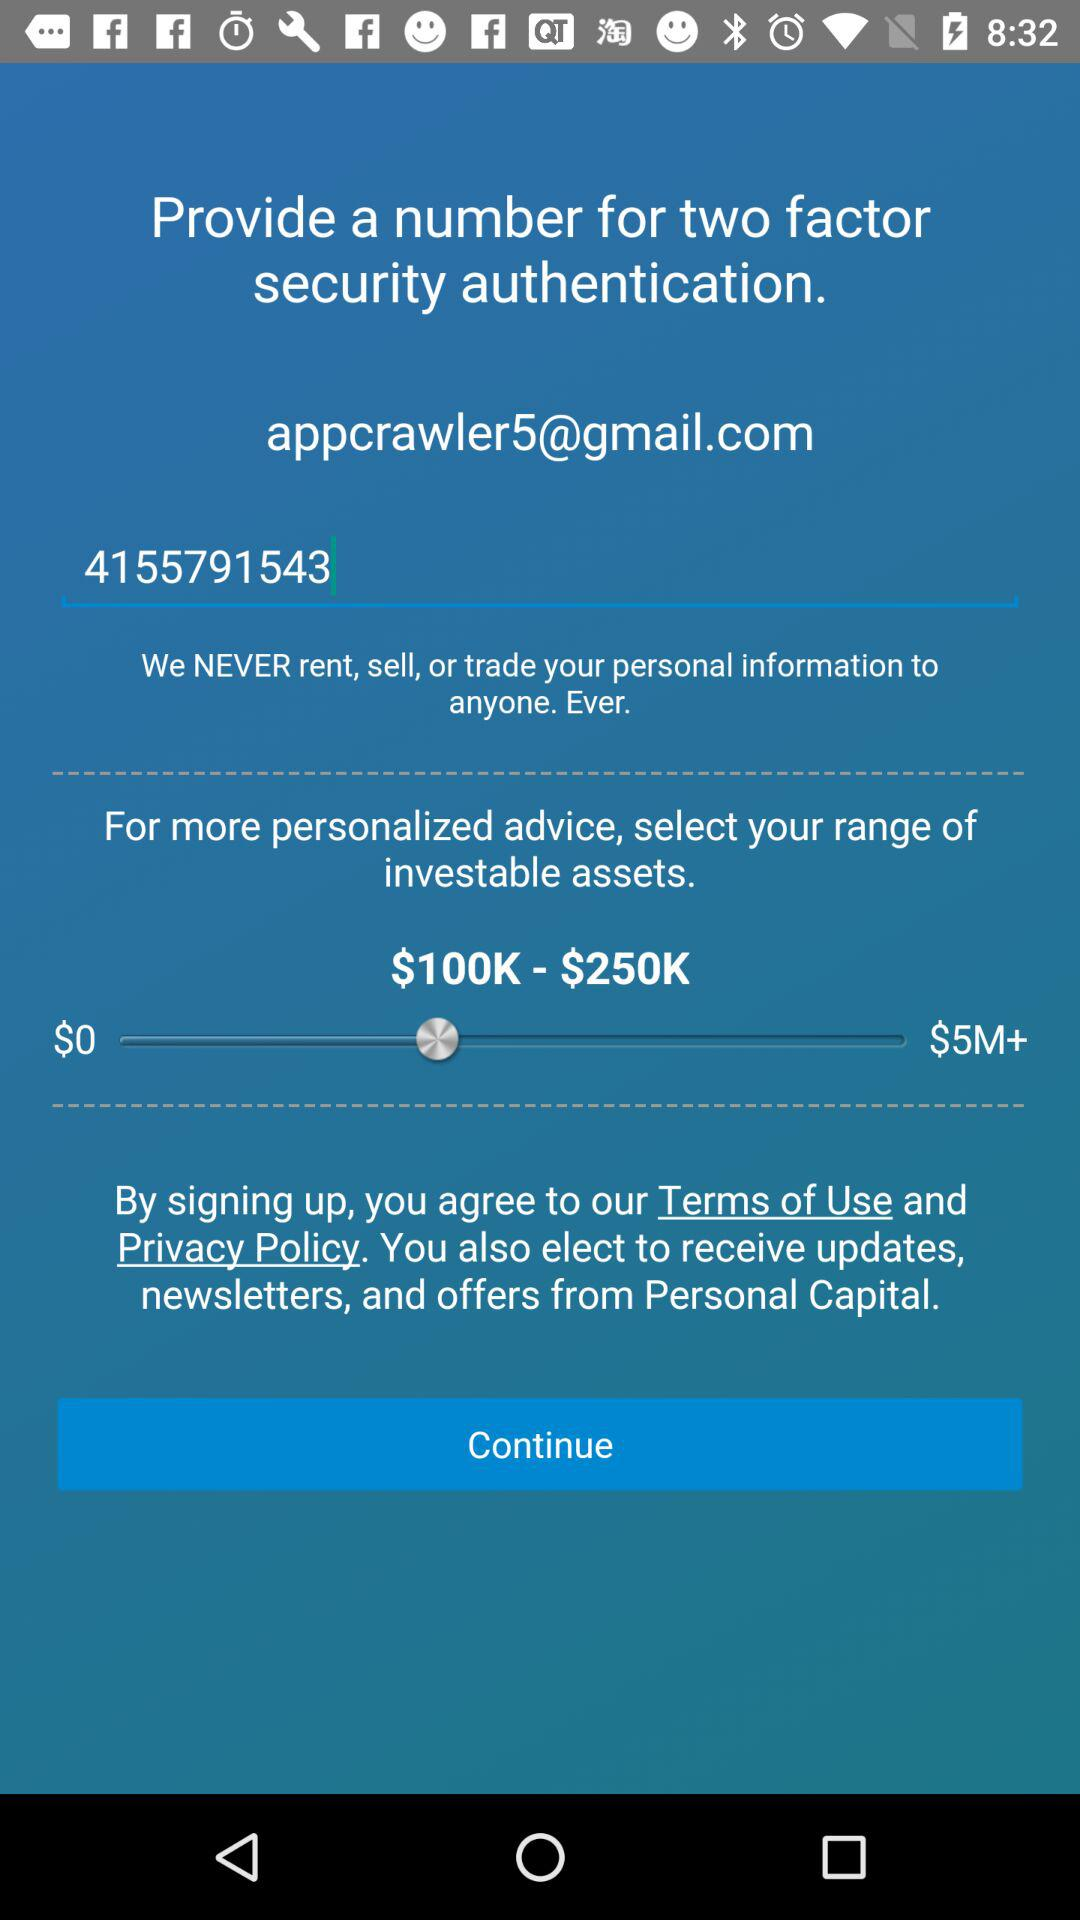What is the number for two-factor security authentication? The number is 4155791543. 